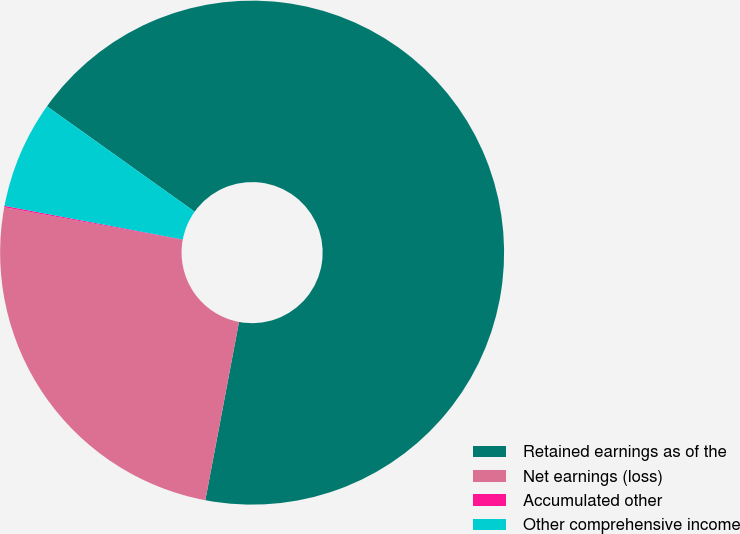Convert chart to OTSL. <chart><loc_0><loc_0><loc_500><loc_500><pie_chart><fcel>Retained earnings as of the<fcel>Net earnings (loss)<fcel>Accumulated other<fcel>Other comprehensive income<nl><fcel>68.11%<fcel>24.91%<fcel>0.09%<fcel>6.89%<nl></chart> 